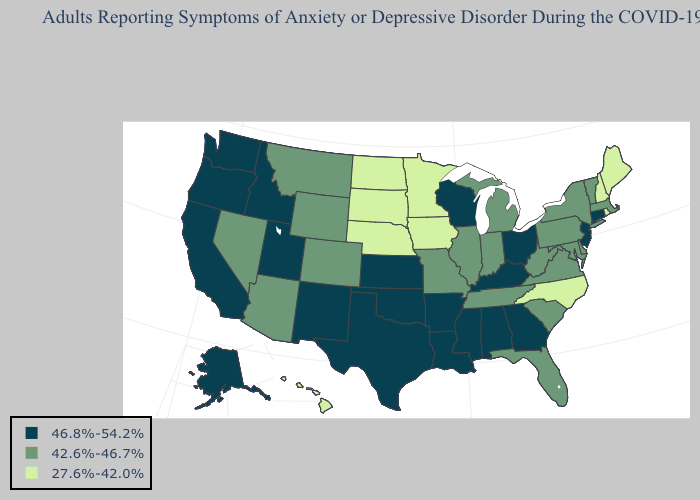Among the states that border Wisconsin , does Michigan have the highest value?
Give a very brief answer. Yes. Among the states that border Minnesota , does South Dakota have the highest value?
Quick response, please. No. Which states have the lowest value in the Northeast?
Short answer required. Maine, New Hampshire, Rhode Island. Does Colorado have the lowest value in the West?
Keep it brief. No. Among the states that border California , does Arizona have the lowest value?
Short answer required. Yes. Among the states that border New Hampshire , does Maine have the highest value?
Write a very short answer. No. What is the lowest value in states that border Rhode Island?
Answer briefly. 42.6%-46.7%. What is the highest value in the USA?
Keep it brief. 46.8%-54.2%. Which states have the highest value in the USA?
Give a very brief answer. Alabama, Alaska, Arkansas, California, Connecticut, Georgia, Idaho, Kansas, Kentucky, Louisiana, Mississippi, New Jersey, New Mexico, Ohio, Oklahoma, Oregon, Texas, Utah, Washington, Wisconsin. Name the states that have a value in the range 27.6%-42.0%?
Quick response, please. Hawaii, Iowa, Maine, Minnesota, Nebraska, New Hampshire, North Carolina, North Dakota, Rhode Island, South Dakota. Name the states that have a value in the range 42.6%-46.7%?
Concise answer only. Arizona, Colorado, Delaware, Florida, Illinois, Indiana, Maryland, Massachusetts, Michigan, Missouri, Montana, Nevada, New York, Pennsylvania, South Carolina, Tennessee, Vermont, Virginia, West Virginia, Wyoming. What is the value of Alaska?
Give a very brief answer. 46.8%-54.2%. Name the states that have a value in the range 27.6%-42.0%?
Concise answer only. Hawaii, Iowa, Maine, Minnesota, Nebraska, New Hampshire, North Carolina, North Dakota, Rhode Island, South Dakota. What is the value of Wyoming?
Answer briefly. 42.6%-46.7%. 